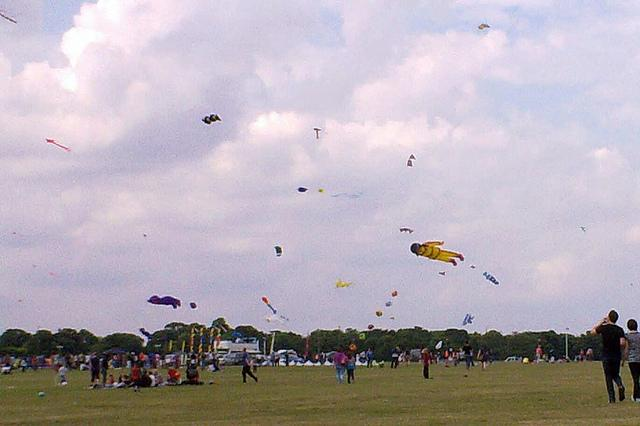What is the largest kite flying made to resemble? person 